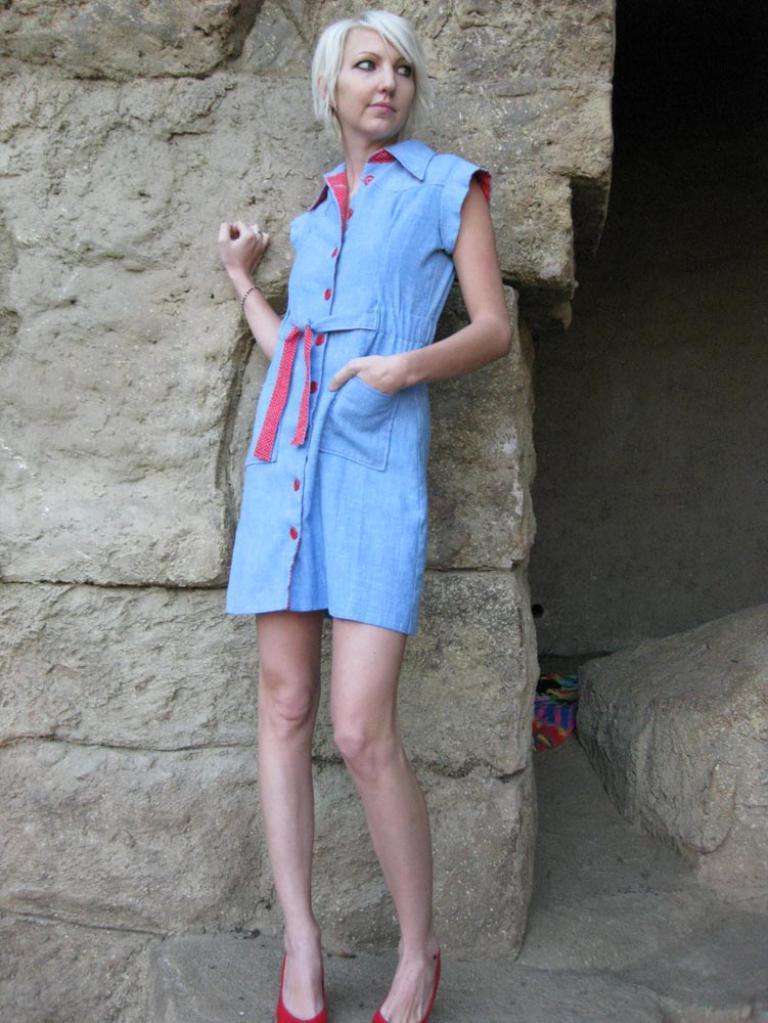Could you give a brief overview of what you see in this image? In this image there is a woman who is wearing the blue dress is standing in the middle. Behind her there is a wall. 